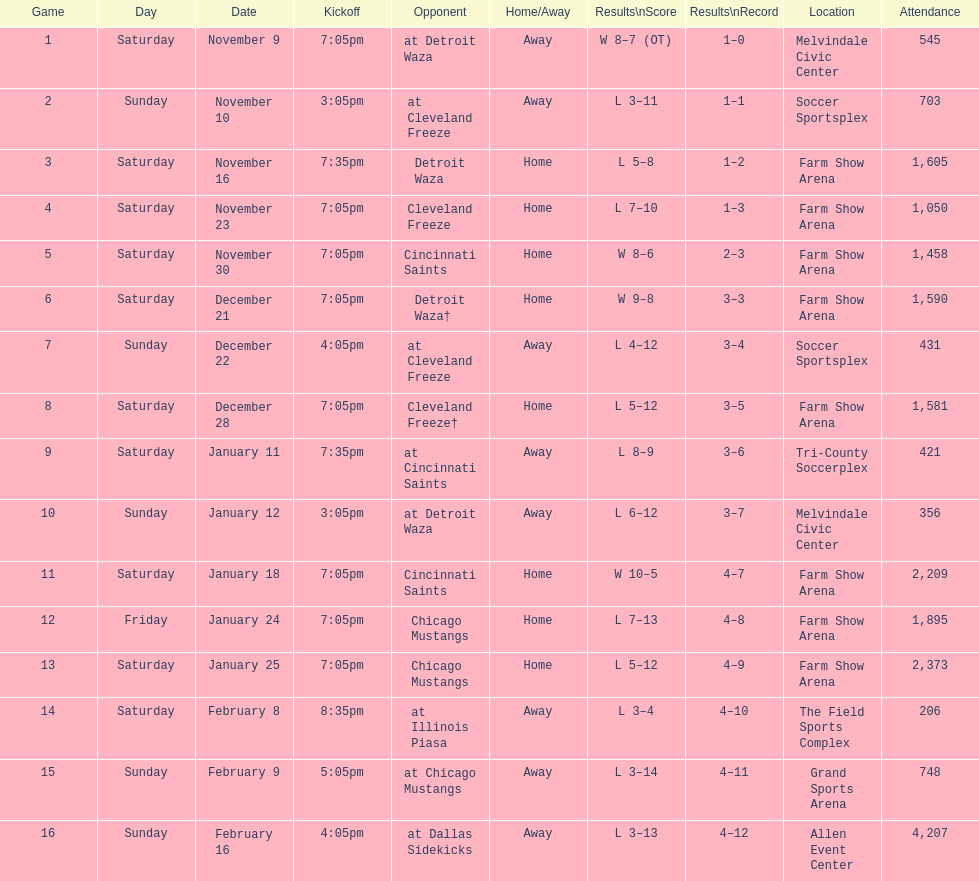How many times did the team play at home but did not win? 5. 